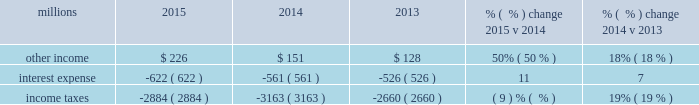Addition , fuel costs were lower as gross-ton miles decreased 9% ( 9 % ) .
The fuel consumption rate ( c-rate ) , computed as gallons of fuel consumed divided by gross ton-miles in thousands , increased 1% ( 1 % ) compared to 2014 .
Decreases in heavier , more fuel-efficient shipments , decreased gross-ton miles and increased the c-rate .
Volume growth of 7% ( 7 % ) , as measured by gross ton-miles , drove the increase in fuel expense in 2014 compared to 2013 .
This was essentially offset by lower locomotive diesel fuel prices , which averaged $ 2.97 per gallon ( including taxes and transportation costs ) in 2014 , compared to $ 3.15 in 2013 , along with a slight improvement in c-rate , computed as gallons of fuel consumed divided by gross ton-miles .
Depreciation 2013 the majority of depreciation relates to road property , including rail , ties , ballast , and other track material .
A higher depreciable asset base , reflecting higher capital spending in recent years , increased depreciation expense in 2015 compared to 2014 .
This increase was partially offset by our recent depreciation studies that resulted in lower depreciation rates for some asset classes .
Depreciation was up 7% ( 7 % ) in 2014 compared to 2013 .
A higher depreciable asset base , reflecting higher ongoing capital spending drove the increase .
Equipment and other rents 2013 equipment and other rents expense primarily includes rental expense that the railroad pays for freight cars owned by other railroads or private companies ; freight car , intermodal , and locomotive leases ; and office and other rent expenses .
Equipment and other rents expense decreased $ 4 million compared to 2014 primarily from a decrease in manifest and intermodal shipments , partially offset by growth in finished vehicle shipments .
Higher intermodal volumes and longer cycle times increased short-term freight car rental expense in 2014 compared to 2013 .
Lower equipment leases essentially offset the higher freight car rental expense , as we exercised purchase options on some of our leased equipment .
Other 2013 other expenses include state and local taxes , freight , equipment and property damage , utilities , insurance , personal injury , environmental , employee travel , telephone and cellular , computer software , bad debt , and other general expenses .
Other expenses were flat in 2015 compared to 2014 as higher property taxes were offset by lower costs in other areas .
Higher property taxes , personal injury expense and utilities costs partially offset by lower environmental expense and costs associated with damaged freight resulted in an increase in other costs in 2014 compared to 2013 .
Non-operating items % (  % ) change % (  % ) change millions 2015 2014 2013 2015 v 2014 2014 v 2013 .
Other income 2013 other income increased in 2015 compared to 2014 primarily due to a $ 113 million gain from a real estate sale in the second quarter of 2015 , partially offset by a gain from the sale of a permanent easement in 2014 .
Other income increased in 2014 versus 2013 due to higher gains from real estate sales and a sale of a permanent easement .
These gains were partially offset by higher environmental costs on non-operating property in 2014 and lower lease income due to the $ 17 million settlement of a land lease contract in interest expense 2013 interest expense increased in 2015 compared to 2014 due to an increased weighted- average debt level of $ 13.0 billion in 2015 from $ 10.7 billion in 2014 , partially offset by the impact of a lower effective interest rate of 4.8% ( 4.8 % ) in 2015 compared to 5.3% ( 5.3 % ) in 2014 .
Interest expense increased in 2014 versus 2013 due to an increased weighted-average debt level of $ 10.7 billion in 2014 from $ 9.6 billion in 2013 , which more than offset the impact of the lower effective interest rate of 5.3% ( 5.3 % ) in 2014 versus 5.7% ( 5.7 % ) in 2013. .
Without the gain of $ 113 million from a real estate sale in the second quarter of 2015 what would other income have been in millions? 
Rationale: an adjustment to remove the extraneous one time event .
Computations: (226 - 113)
Answer: 113.0. 